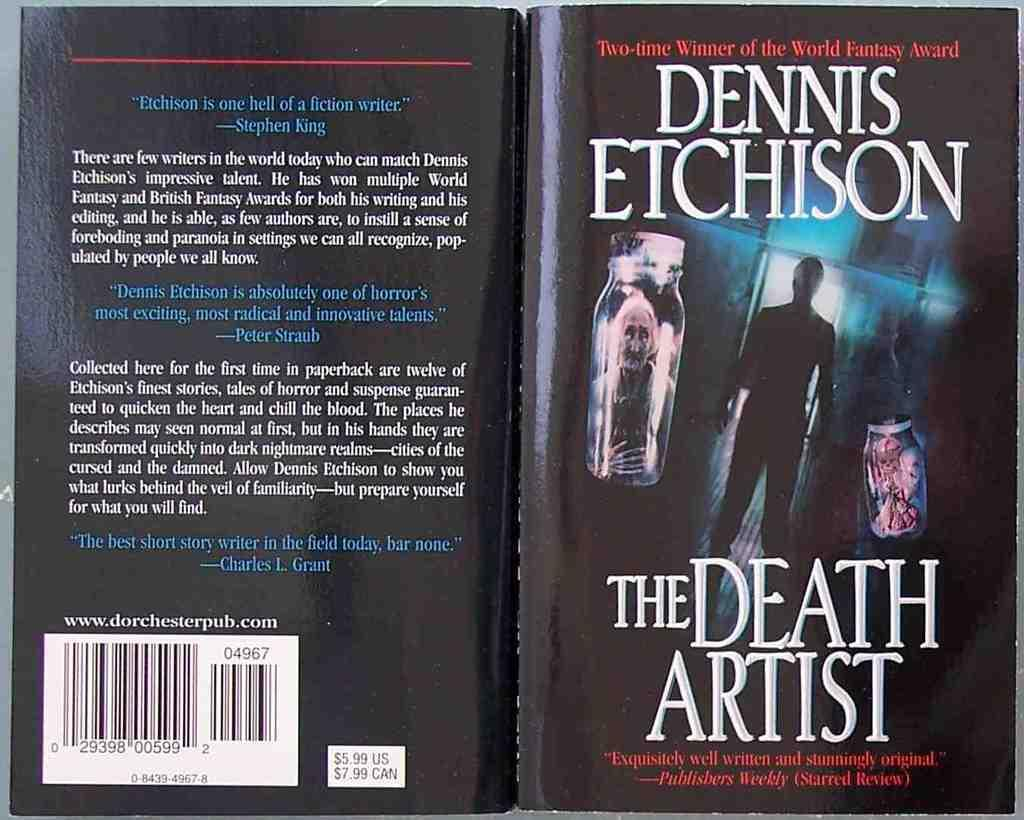<image>
Present a compact description of the photo's key features. A black book cover of a book by Dennis Etchison titled The Death Artist. 